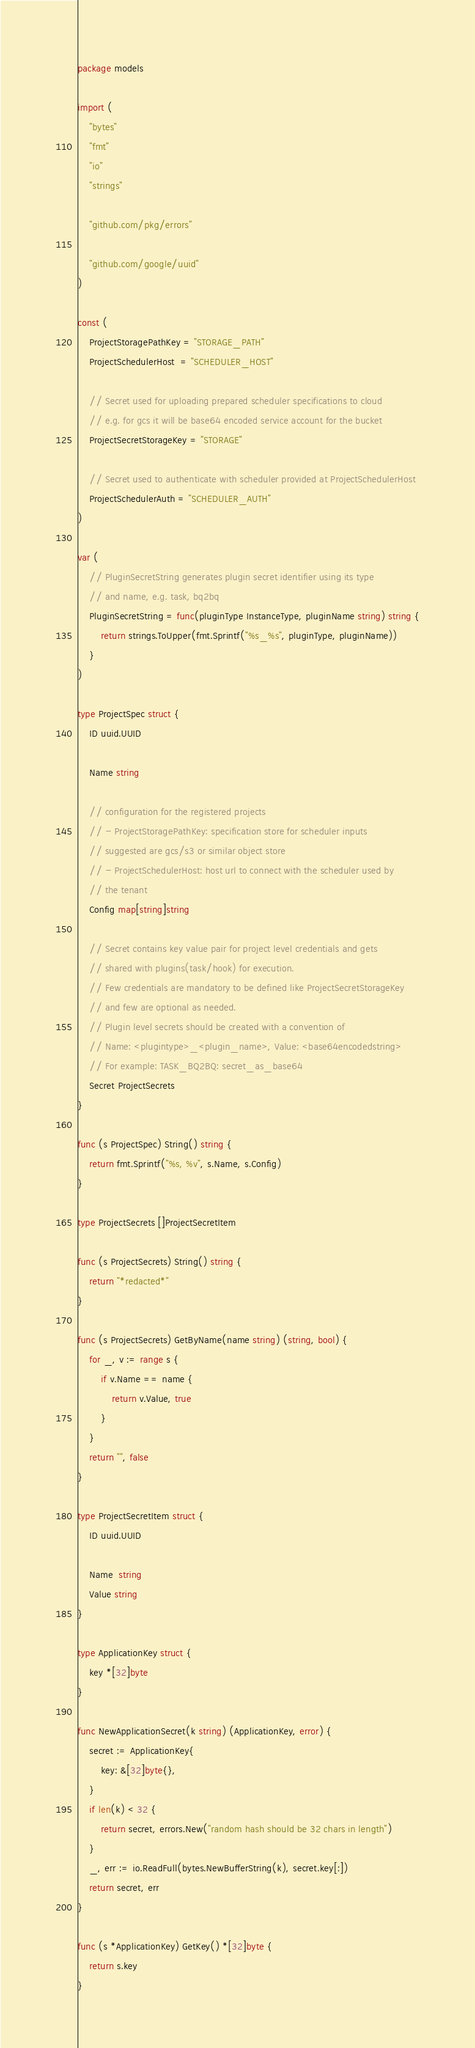Convert code to text. <code><loc_0><loc_0><loc_500><loc_500><_Go_>package models

import (
	"bytes"
	"fmt"
	"io"
	"strings"

	"github.com/pkg/errors"

	"github.com/google/uuid"
)

const (
	ProjectStoragePathKey = "STORAGE_PATH"
	ProjectSchedulerHost  = "SCHEDULER_HOST"

	// Secret used for uploading prepared scheduler specifications to cloud
	// e.g. for gcs it will be base64 encoded service account for the bucket
	ProjectSecretStorageKey = "STORAGE"

	// Secret used to authenticate with scheduler provided at ProjectSchedulerHost
	ProjectSchedulerAuth = "SCHEDULER_AUTH"
)

var (
	// PluginSecretString generates plugin secret identifier using its type
	// and name, e.g. task, bq2bq
	PluginSecretString = func(pluginType InstanceType, pluginName string) string {
		return strings.ToUpper(fmt.Sprintf("%s_%s", pluginType, pluginName))
	}
)

type ProjectSpec struct {
	ID uuid.UUID

	Name string

	// configuration for the registered projects
	// - ProjectStoragePathKey: specification store for scheduler inputs
	// suggested are gcs/s3 or similar object store
	// - ProjectSchedulerHost: host url to connect with the scheduler used by
	// the tenant
	Config map[string]string

	// Secret contains key value pair for project level credentials and gets
	// shared with plugins(task/hook) for execution.
	// Few credentials are mandatory to be defined like ProjectSecretStorageKey
	// and few are optional as needed.
	// Plugin level secrets should be created with a convention of
	// Name: <plugintype>_<plugin_name>, Value: <base64encodedstring>
	// For example: TASK_BQ2BQ: secret_as_base64
	Secret ProjectSecrets
}

func (s ProjectSpec) String() string {
	return fmt.Sprintf("%s, %v", s.Name, s.Config)
}

type ProjectSecrets []ProjectSecretItem

func (s ProjectSecrets) String() string {
	return "*redacted*"
}

func (s ProjectSecrets) GetByName(name string) (string, bool) {
	for _, v := range s {
		if v.Name == name {
			return v.Value, true
		}
	}
	return "", false
}

type ProjectSecretItem struct {
	ID uuid.UUID

	Name  string
	Value string
}

type ApplicationKey struct {
	key *[32]byte
}

func NewApplicationSecret(k string) (ApplicationKey, error) {
	secret := ApplicationKey{
		key: &[32]byte{},
	}
	if len(k) < 32 {
		return secret, errors.New("random hash should be 32 chars in length")
	}
	_, err := io.ReadFull(bytes.NewBufferString(k), secret.key[:])
	return secret, err
}

func (s *ApplicationKey) GetKey() *[32]byte {
	return s.key
}
</code> 